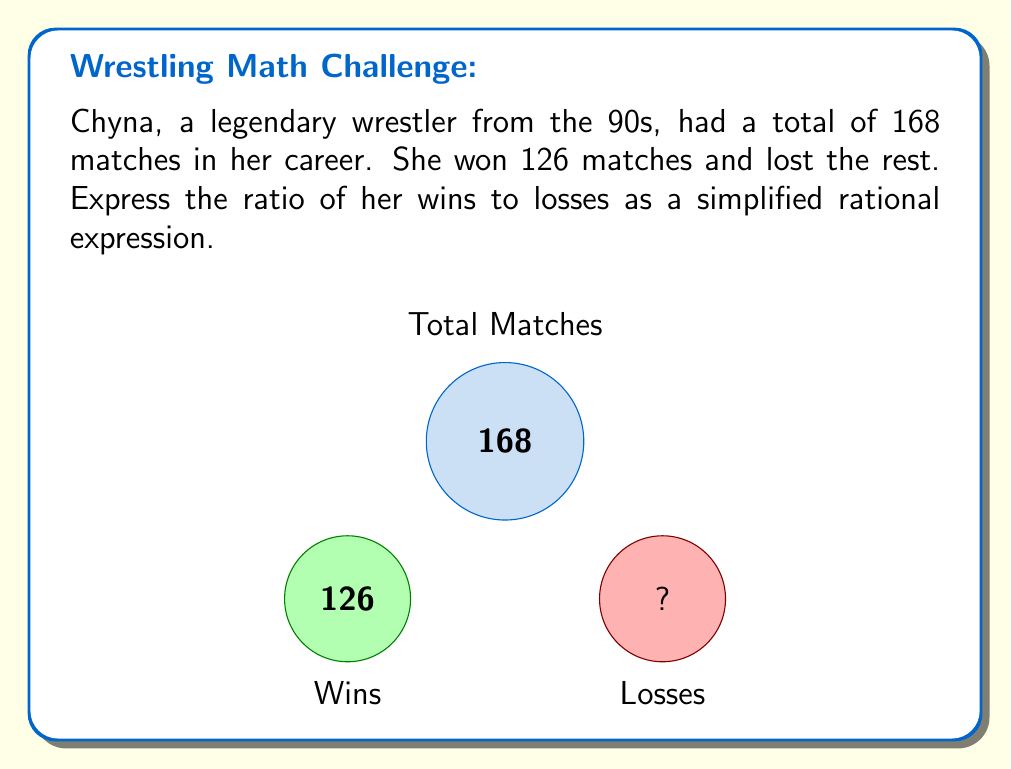Teach me how to tackle this problem. Let's approach this step-by-step:

1) First, we need to calculate the number of losses:
   Total matches = 168
   Wins = 126
   Losses = 168 - 126 = 42

2) Now we can set up the ratio of wins to losses:
   $\frac{\text{Wins}}{\text{Losses}} = \frac{126}{42}$

3) To simplify this rational expression, we need to find the greatest common divisor (GCD) of 126 and 42:
   
   126 = 2 × 3 × 3 × 7
   42 = 2 × 3 × 7
   
   GCD = 2 × 3 × 7 = 42

4) Divide both the numerator and denominator by the GCD:

   $$\frac{126}{42} = \frac{126 \div 42}{42 \div 42} = \frac{3}{1}$$

Therefore, the simplified ratio of Chyna's wins to losses is 3:1.
Answer: $\frac{3}{1}$ or 3:1 